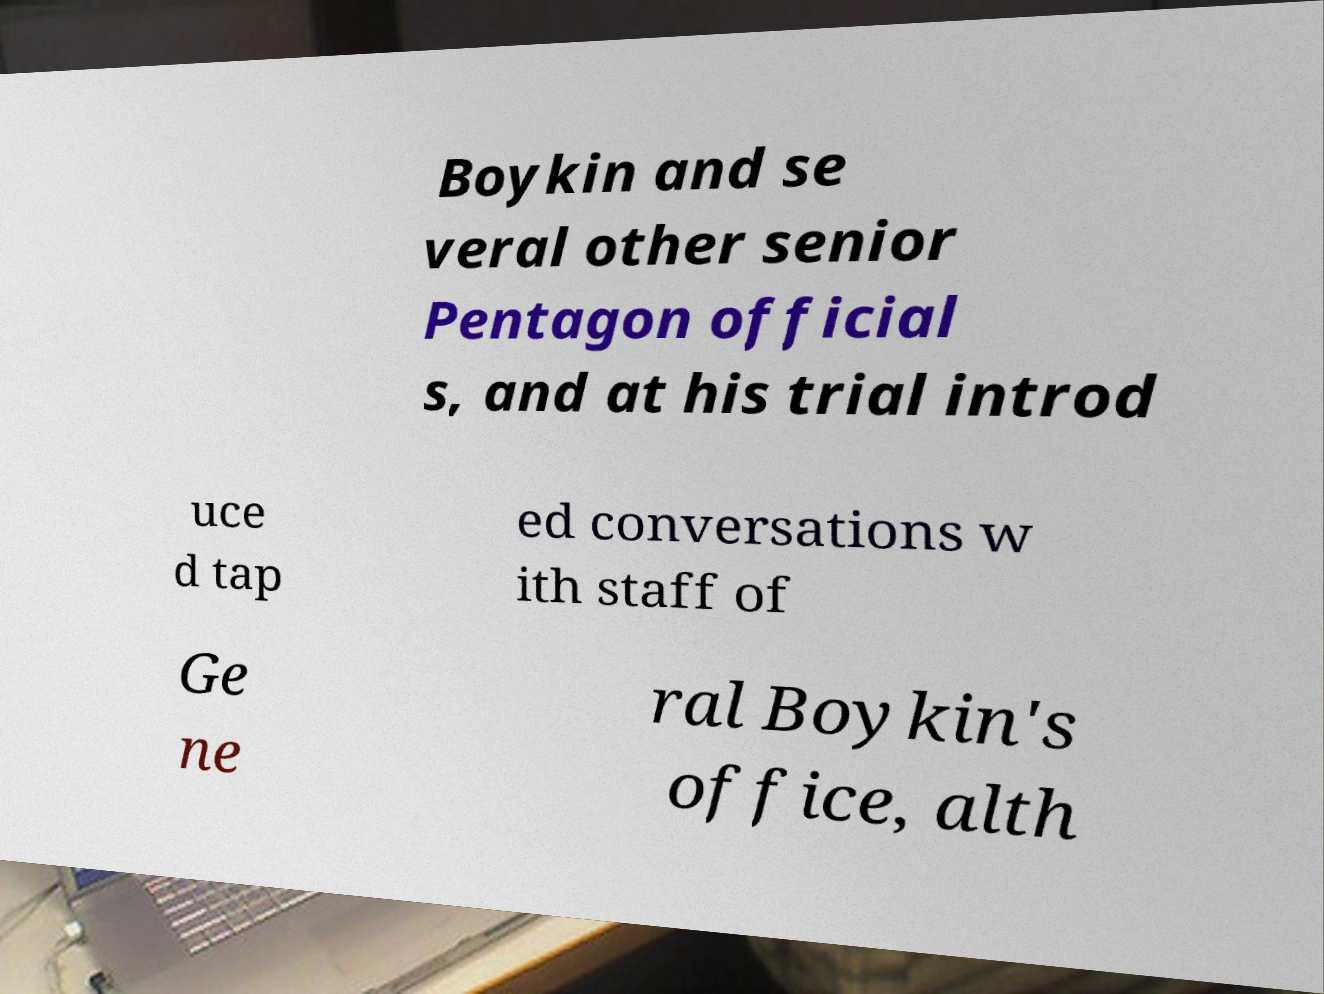Could you extract and type out the text from this image? Boykin and se veral other senior Pentagon official s, and at his trial introd uce d tap ed conversations w ith staff of Ge ne ral Boykin's office, alth 